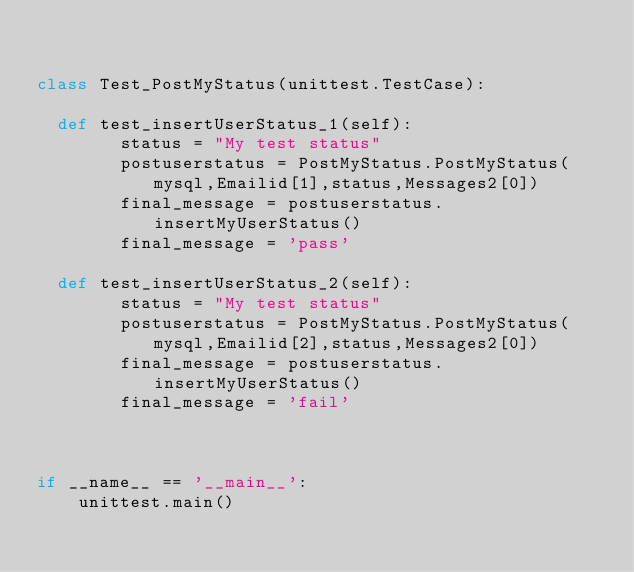<code> <loc_0><loc_0><loc_500><loc_500><_Python_>

class Test_PostMyStatus(unittest.TestCase):

  def test_insertUserStatus_1(self):
        status = "My test status"
        postuserstatus = PostMyStatus.PostMyStatus(mysql,Emailid[1],status,Messages2[0])
        final_message = postuserstatus.insertMyUserStatus()
        final_message = 'pass'

  def test_insertUserStatus_2(self):
        status = "My test status"
        postuserstatus = PostMyStatus.PostMyStatus(mysql,Emailid[2],status,Messages2[0])
        final_message = postuserstatus.insertMyUserStatus()
        final_message = 'fail'



if __name__ == '__main__':
    unittest.main()
</code> 